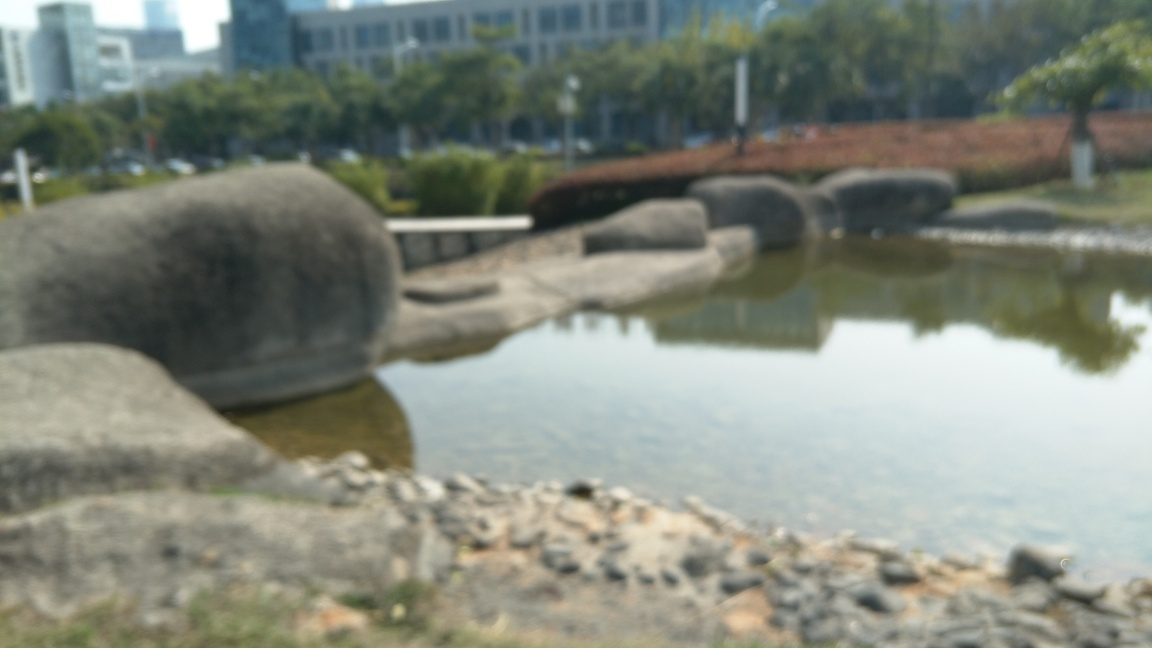Have the main subjects lost most of their texture details?
A. No
B. Yes
Answer with the option's letter from the given choices directly.
 B. 